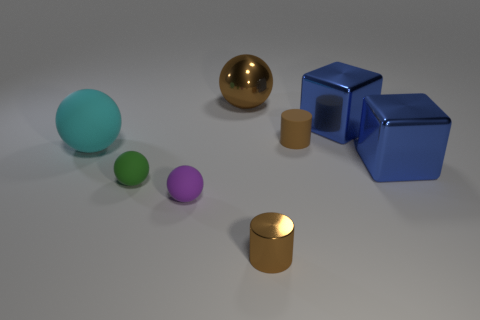What time of day does the lighting in the image suggest? The lighting in the image appears to be neutral and diffused, which doesn't suggest a particular time of day. It's more indicative of an indoor setting with controlled lighting such as studio lighting, used to minimize shadows and evenly illuminate the objects. How could the lighting affect the perception of the object's materials? Controlled lighting can influence the way materials are perceived. For instance, without strong directional light, reflective properties might be less apparent, and it could be harder to distinguish between matte and glossy surfaces or identify textures that would be more obvious with directional lighting that produces shadows and highlights. 